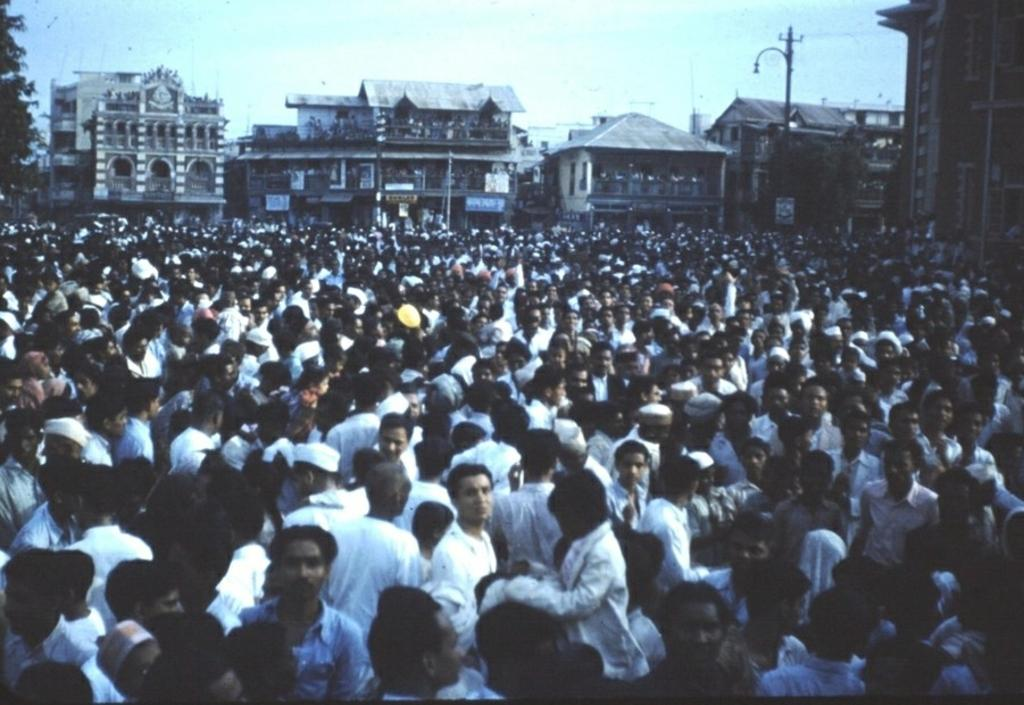What is the main subject of the image? The main subject of the image is a crowd. Where is the crowd located in relation to other structures? The crowd is in front of buildings. What can be seen in the top right corner of the image? There is a pole in the top right corner of the image. What is visible at the top of the image? The sky is visible at the top of the image. How many pies are being sold by the crowd in the image? There is no mention of pies or any sales activity in the image; it simply shows a crowd in front of buildings. Can you provide an example of a person in the crowd who is wearing a hat? The image does not provide enough detail to identify individual people or their clothing, so it is not possible to give an example of someone wearing a hat. 